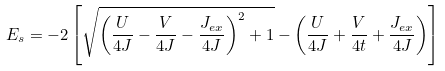<formula> <loc_0><loc_0><loc_500><loc_500>E _ { s } = - 2 \left [ \sqrt { { \left ( \frac { U } { 4 J } - \frac { V } { 4 J } - \frac { J _ { e x } } { 4 J } \right ) ^ { 2 } } + 1 } - \left ( \frac { U } { 4 J } + \frac { V } { 4 t } + \frac { J _ { e x } } { 4 J } \right ) \right ]</formula> 